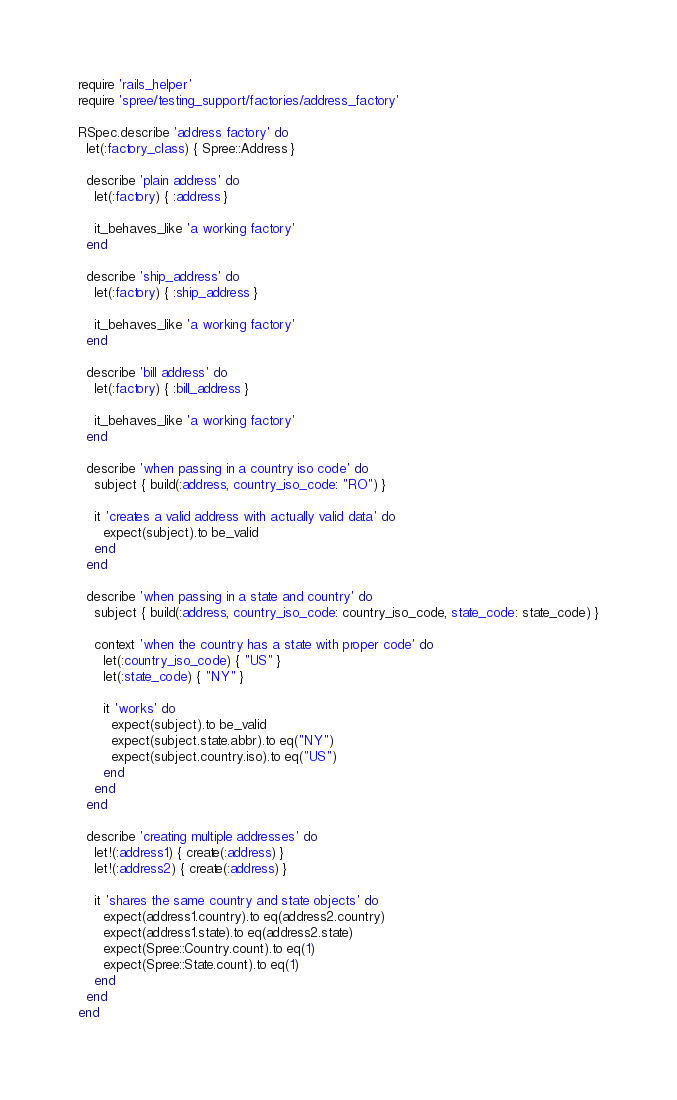Convert code to text. <code><loc_0><loc_0><loc_500><loc_500><_Ruby_>require 'rails_helper'
require 'spree/testing_support/factories/address_factory'

RSpec.describe 'address factory' do
  let(:factory_class) { Spree::Address }

  describe 'plain address' do
    let(:factory) { :address }

    it_behaves_like 'a working factory'
  end

  describe 'ship_address' do
    let(:factory) { :ship_address }

    it_behaves_like 'a working factory'
  end

  describe 'bill address' do
    let(:factory) { :bill_address }

    it_behaves_like 'a working factory'
  end

  describe 'when passing in a country iso code' do
    subject { build(:address, country_iso_code: "RO") }

    it 'creates a valid address with actually valid data' do
      expect(subject).to be_valid
    end
  end

  describe 'when passing in a state and country' do
    subject { build(:address, country_iso_code: country_iso_code, state_code: state_code) }

    context 'when the country has a state with proper code' do
      let(:country_iso_code) { "US" }
      let(:state_code) { "NY" }

      it 'works' do
        expect(subject).to be_valid
        expect(subject.state.abbr).to eq("NY")
        expect(subject.country.iso).to eq("US")
      end
    end
  end

  describe 'creating multiple addresses' do
    let!(:address1) { create(:address) }
    let!(:address2) { create(:address) }

    it 'shares the same country and state objects' do
      expect(address1.country).to eq(address2.country)
      expect(address1.state).to eq(address2.state)
      expect(Spree::Country.count).to eq(1)
      expect(Spree::State.count).to eq(1)
    end
  end
end
</code> 